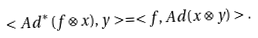<formula> <loc_0><loc_0><loc_500><loc_500>< A d ^ { * } ( f \otimes x ) , y > = < f , A d ( x \otimes y ) > .</formula> 